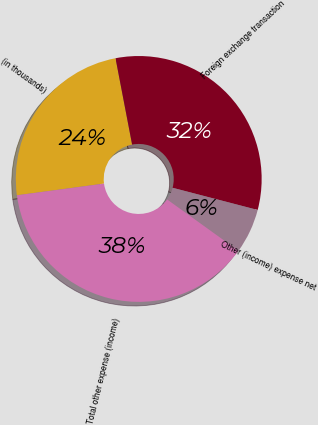Convert chart. <chart><loc_0><loc_0><loc_500><loc_500><pie_chart><fcel>(in thousands)<fcel>Foreign exchange transaction<fcel>Other (income) expense net<fcel>Total other expense (income)<nl><fcel>24.1%<fcel>32.08%<fcel>5.87%<fcel>37.95%<nl></chart> 